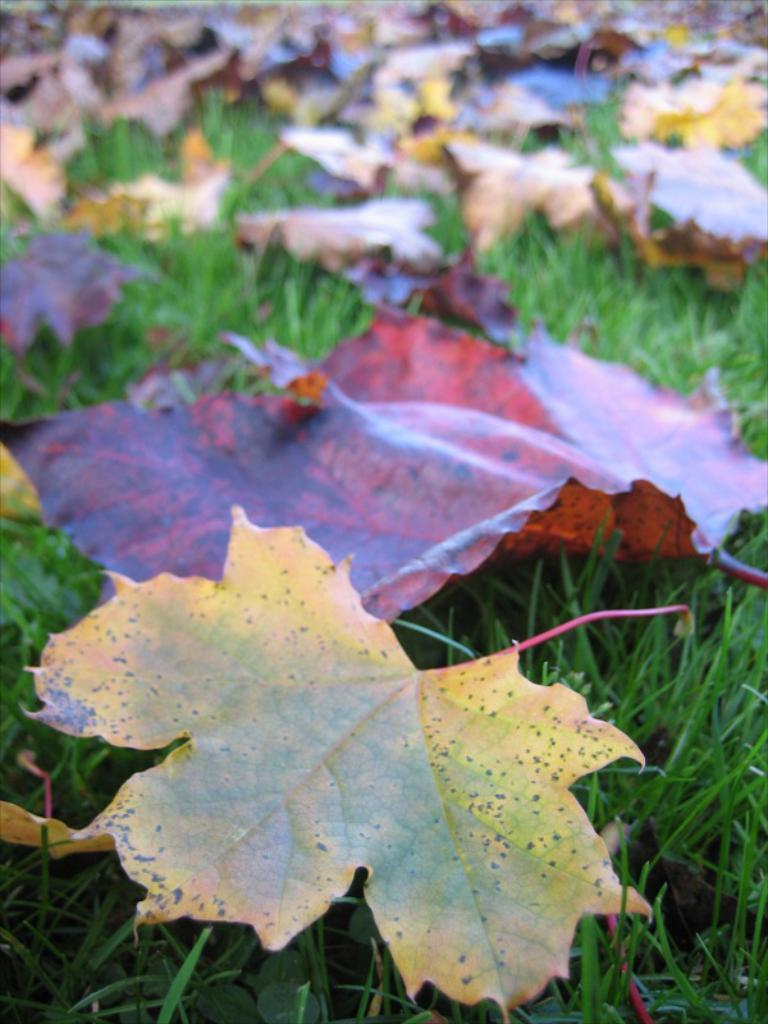What type of surface is visible in the picture? There is a grass surface in the picture. What can be found on the grass surface? There are maple leaves on the grass surface. What type of reaction can be seen from the rifle on the shelf in the image? There is no rifle or shelf present in the image; it only features a grass surface with maple leaves. 